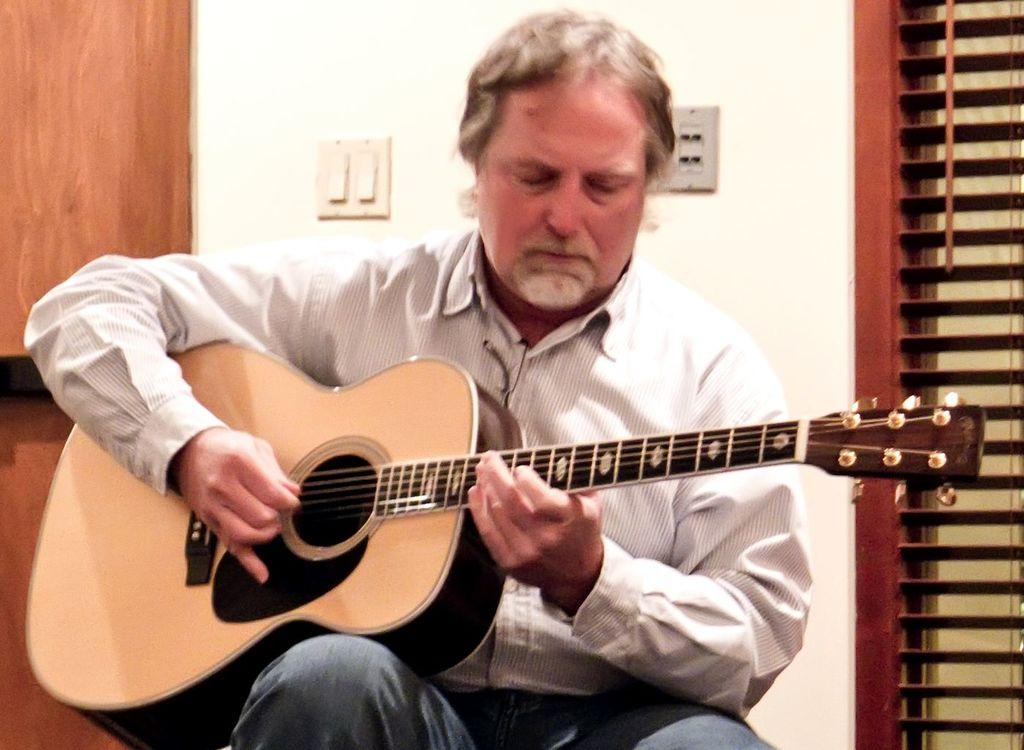What is the man in the image doing? The man is playing a guitar in the image. Can you describe the man's activity in more detail? The man is playing a guitar, which suggests he might be a musician or performing for an audience. What can be seen in the background of the image? There are switches visible in the background of the image. How does the man's digestion process affect the sound of the guitar in the image? There is no information about the man's digestion process in the image, and it is not relevant to the man's activity of playing a guitar. 